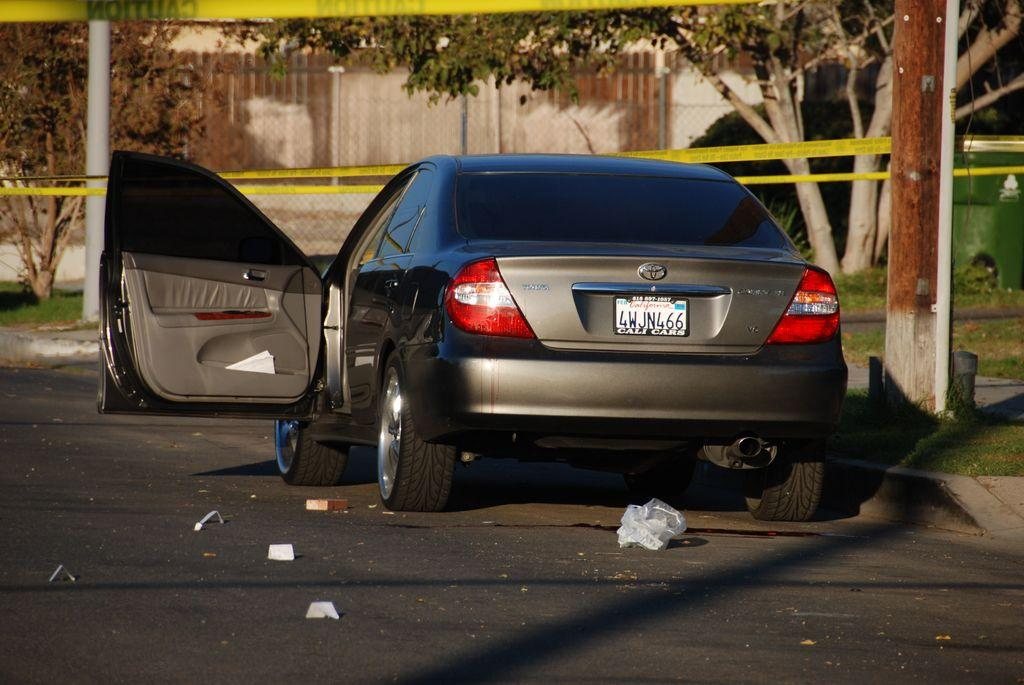What is the main subject of the image? There is a car in the image. What is on the road near the car? There are papers on the road in the image. What type of natural elements can be seen in the image? There are trees in the image. What additional objects can be seen in the image? There is a ribbon and a pole in the image. What type of structure is present in the image? There is a wall in the image. What type of help can be seen being offered at the cemetery in the image? There is no cemetery present in the image, and therefore no help can be seen being offered. What route is the car taking in the image? The image does not provide information about the car's route, only its presence and the objects around it. 